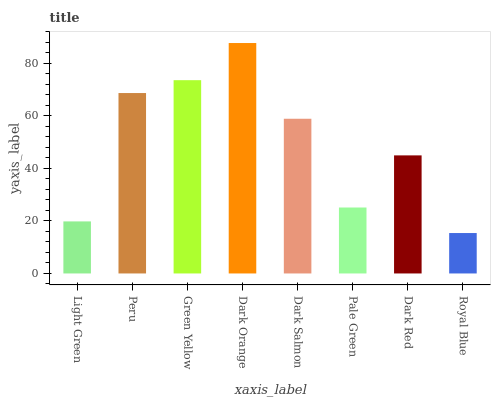Is Royal Blue the minimum?
Answer yes or no. Yes. Is Dark Orange the maximum?
Answer yes or no. Yes. Is Peru the minimum?
Answer yes or no. No. Is Peru the maximum?
Answer yes or no. No. Is Peru greater than Light Green?
Answer yes or no. Yes. Is Light Green less than Peru?
Answer yes or no. Yes. Is Light Green greater than Peru?
Answer yes or no. No. Is Peru less than Light Green?
Answer yes or no. No. Is Dark Salmon the high median?
Answer yes or no. Yes. Is Dark Red the low median?
Answer yes or no. Yes. Is Royal Blue the high median?
Answer yes or no. No. Is Royal Blue the low median?
Answer yes or no. No. 